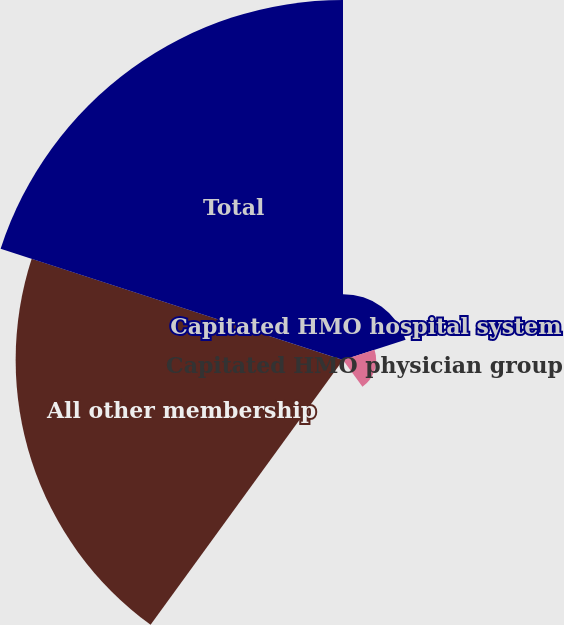Convert chart to OTSL. <chart><loc_0><loc_0><loc_500><loc_500><pie_chart><fcel>Capitated HMO hospital system<fcel>Capitated HMO physician group<fcel>Risk-sharing<fcel>All other membership<fcel>Total<nl><fcel>8.37%<fcel>4.21%<fcel>0.06%<fcel>41.6%<fcel>45.75%<nl></chart> 